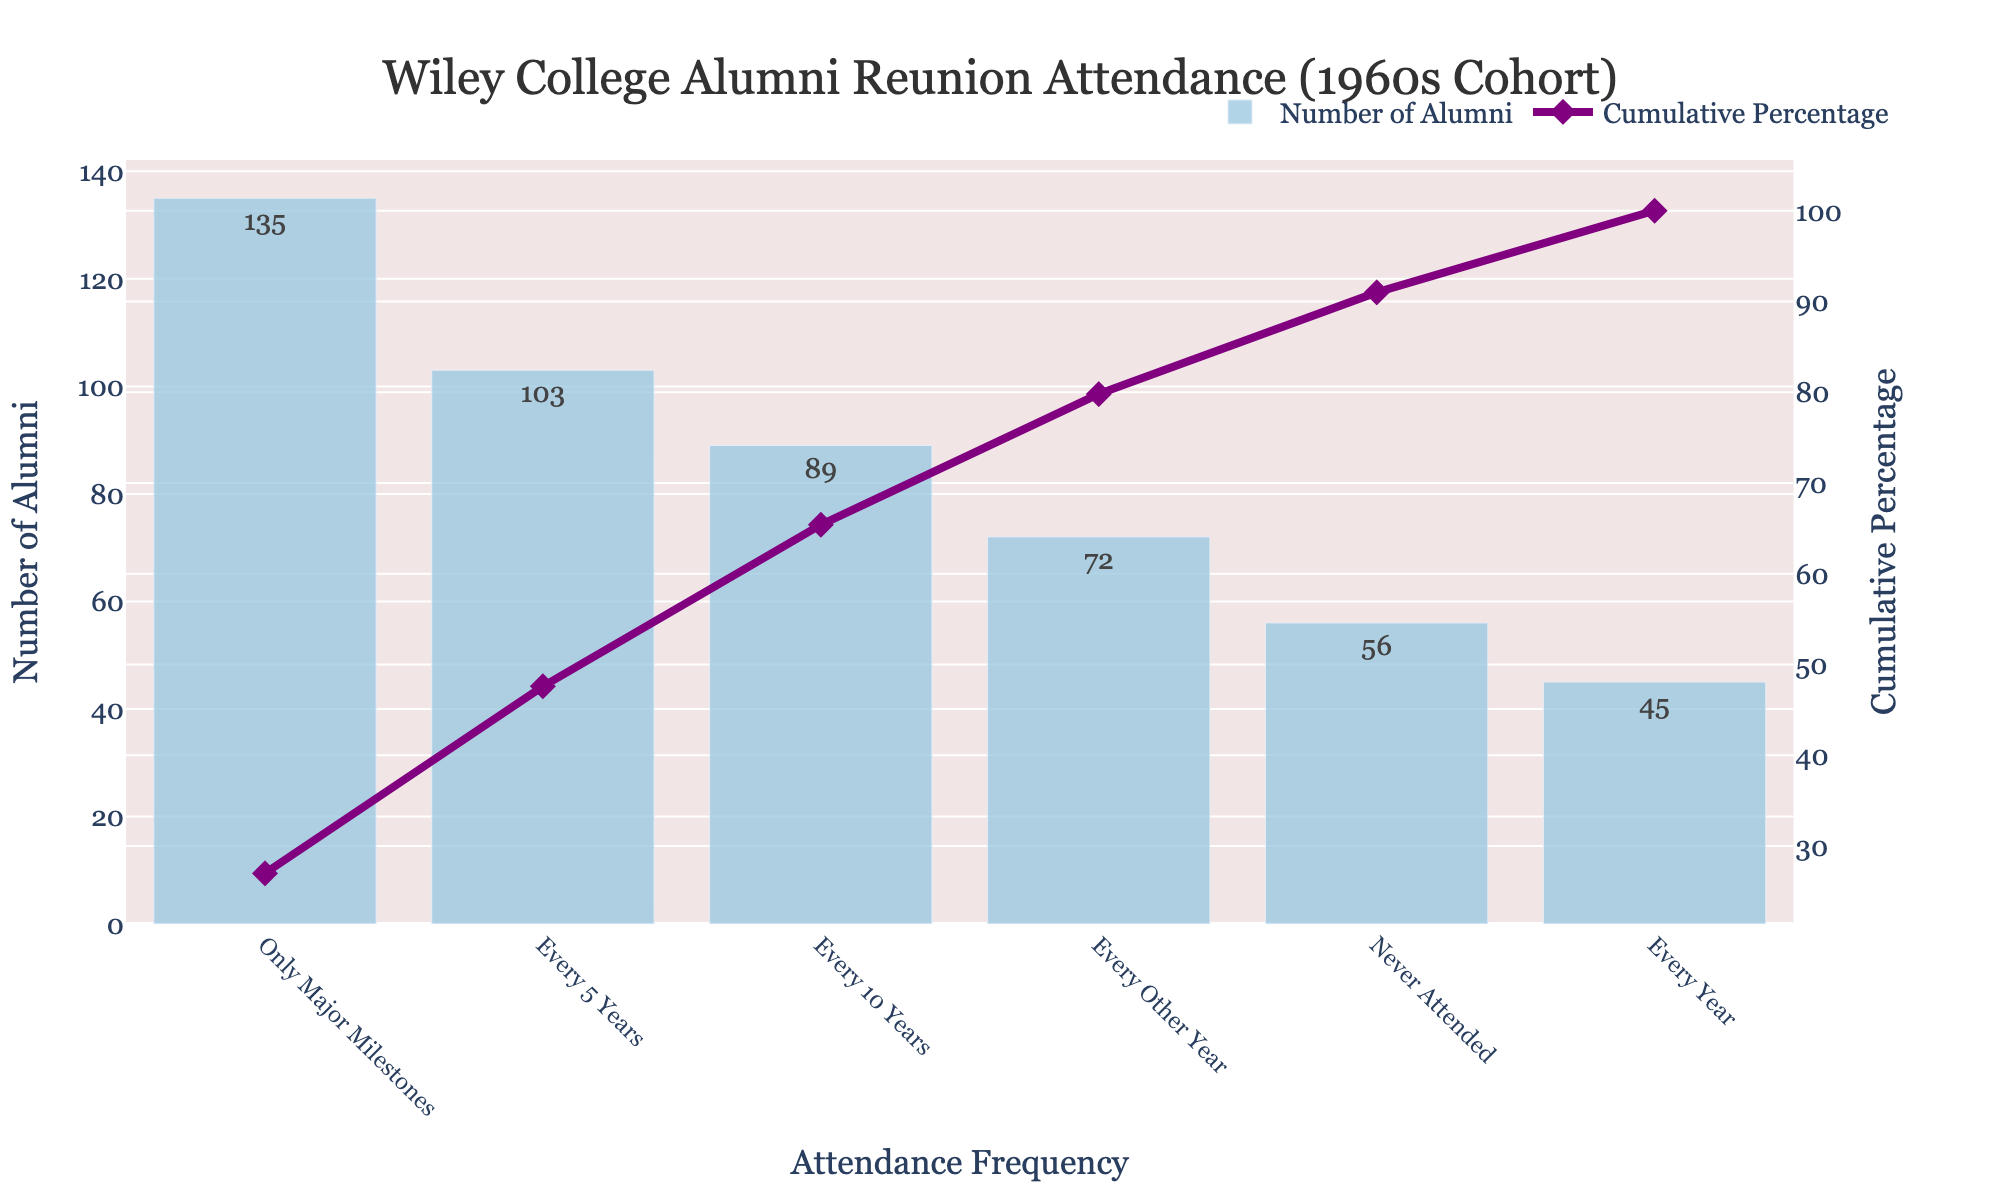How many alumni attend reunions every year? By looking at the data and the bar heights labeled "Every Year" in the chart, we can see the number of alumni that attend each year.
Answer: 45 What is the most common frequency of reunion attendance? The highest bar in the chart represents the most common frequency. In this chart, the largest bar corresponds to "Only Major Milestones."
Answer: Only Major Milestones Which attendance frequency has the lowest number of alumni? The shortest bar in the chart indicates the lowest number of alumni for a specific attendance frequency, which is "Every Year."
Answer: Every Year What is the cumulative percentage of alumni that attend reunions either every year or every other year? The cumulative percentage line at the "Every Other Year" mark gives the combined cumulative percentage of "Every Year" and "Every Other Year." Summing the number of alumni for these two categories and calculating their cumulative percentage verifies this.
Answer: 23% How many alumni never attended a reunion? The bar labeled "Never Attended" indicates the number of alumni who have never attended a reunion.
Answer: 56 Between attending "Every 5 Years" and "Every 10 Years," which is more common? Compare the heights of the bars labeled "Every 5 Years" and "Every 10 Years." "Every 5 Years" has a taller bar, indicating it is more common.
Answer: Every 5 Years What is the cumulative percentage after including alumni who attend every 10 years? The cumulative percentage at "Every 10 Years" from the cumulative percentage line gives this value.
Answer: Approximately 79% How much higher is the number of alumni attending on major milestones compared to those that never attended? Find the difference between the number of alumni attending on major milestones and those never attending by subtracting the value of the "Never Attended" bar from the "Only Major Milestones" bar.
Answer: 79 more alumni How many total alumni are represented in this chart? Sum the number of alumni from all attendance frequencies to get the total count. Adding the values (45 + 72 + 103 + 89 + 135 + 56) provides the total.
Answer: 500 What percentage of alumni attend reunions every 5 or more years, combining every 5 years, every 10 years, and only major milestones? Sum the number of alumni for these frequencies and then calculate the percentage out of the total number of alumni: (103 + 89 + 135) / 500 * 100.
Answer: About 65% 